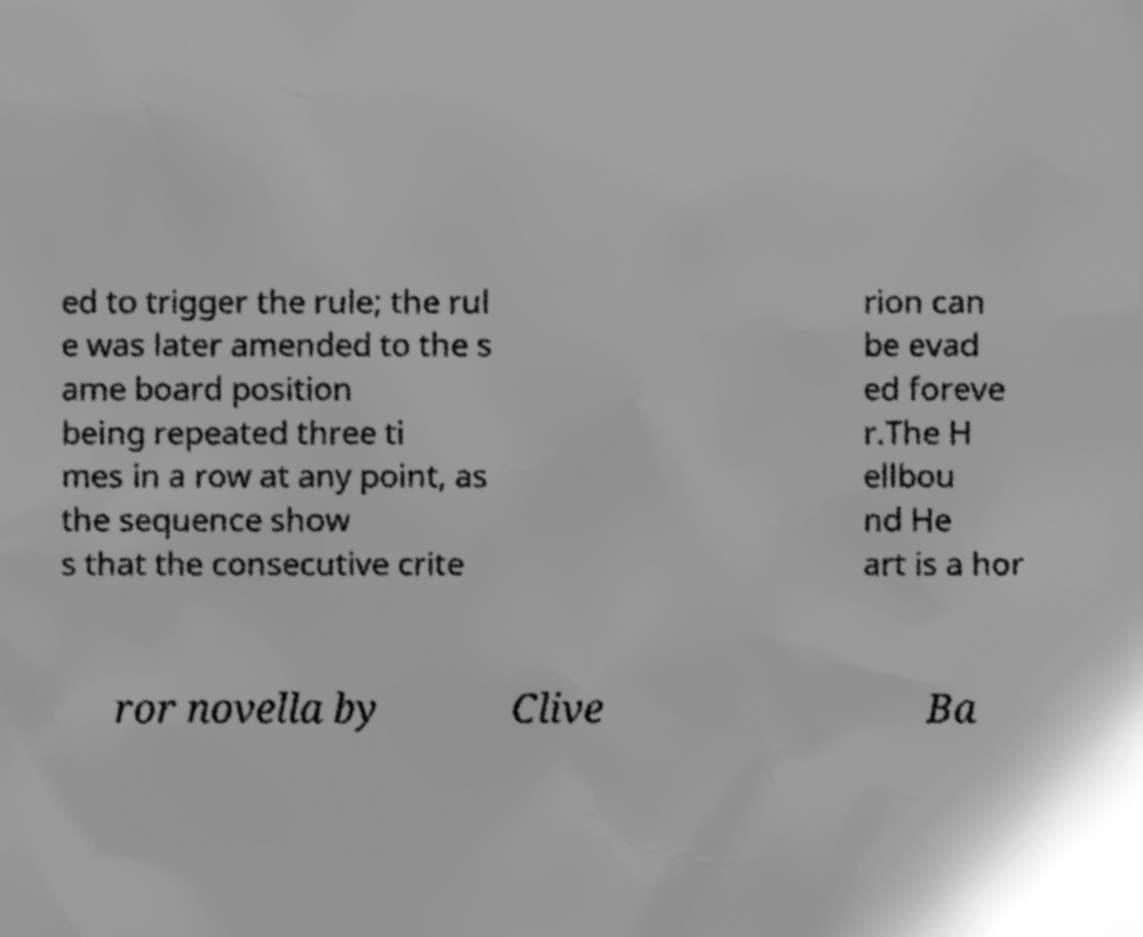Could you assist in decoding the text presented in this image and type it out clearly? ed to trigger the rule; the rul e was later amended to the s ame board position being repeated three ti mes in a row at any point, as the sequence show s that the consecutive crite rion can be evad ed foreve r.The H ellbou nd He art is a hor ror novella by Clive Ba 